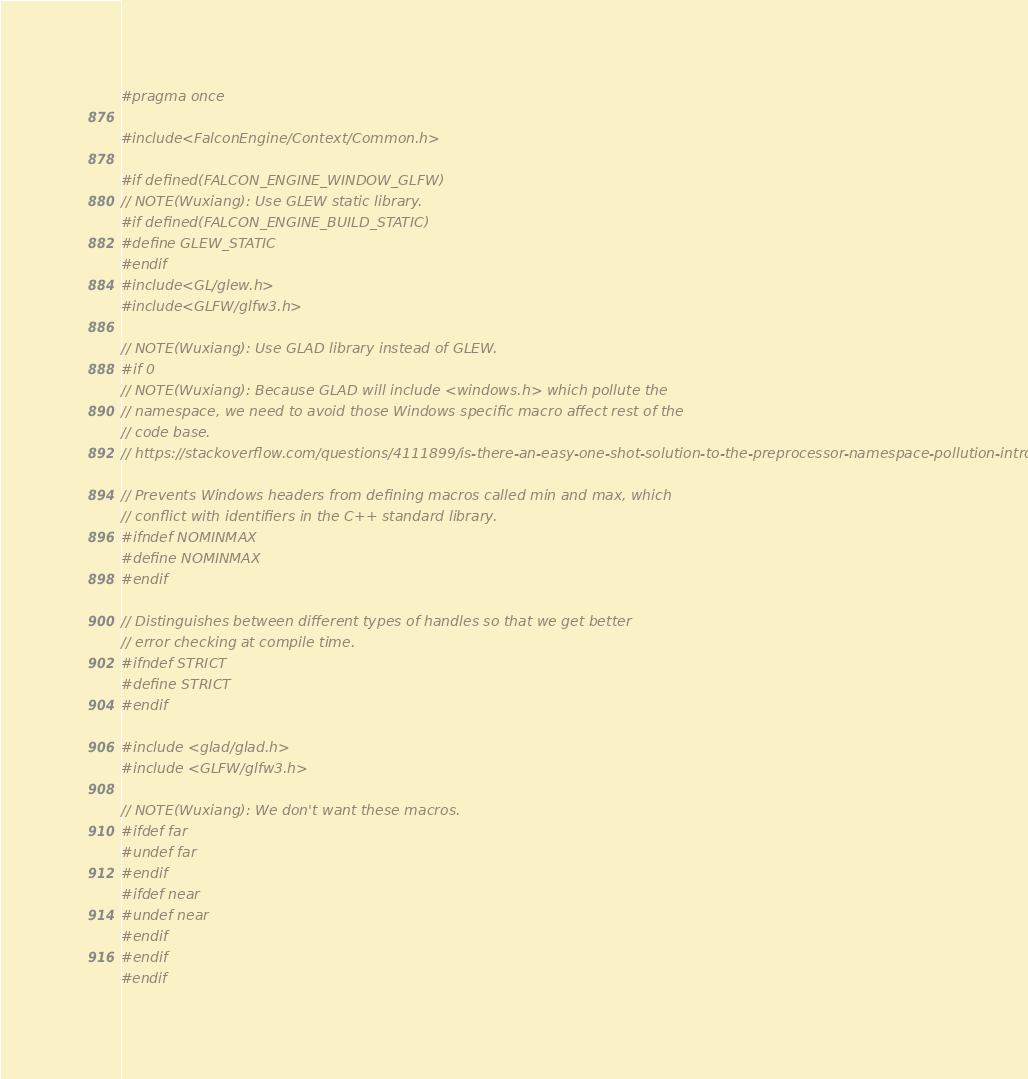Convert code to text. <code><loc_0><loc_0><loc_500><loc_500><_C_>#pragma once

#include <FalconEngine/Context/Common.h>

#if defined(FALCON_ENGINE_WINDOW_GLFW)
// NOTE(Wuxiang): Use GLEW static library.
#if defined(FALCON_ENGINE_BUILD_STATIC)
#define GLEW_STATIC
#endif
#include <GL/glew.h>
#include <GLFW/glfw3.h>

// NOTE(Wuxiang): Use GLAD library instead of GLEW.
#if 0
// NOTE(Wuxiang): Because GLAD will include <windows.h> which pollute the
// namespace, we need to avoid those Windows specific macro affect rest of the
// code base.
// https://stackoverflow.com/questions/4111899/is-there-an-easy-one-shot-solution-to-the-preprocessor-namespace-pollution-intro

// Prevents Windows headers from defining macros called min and max, which
// conflict with identifiers in the C++ standard library.
#ifndef NOMINMAX
#define NOMINMAX
#endif

// Distinguishes between different types of handles so that we get better
// error checking at compile time.
#ifndef STRICT
#define STRICT
#endif

#include <glad/glad.h>
#include <GLFW/glfw3.h>

// NOTE(Wuxiang): We don't want these macros.
#ifdef far
#undef far
#endif
#ifdef near
#undef near
#endif
#endif
#endif
</code> 